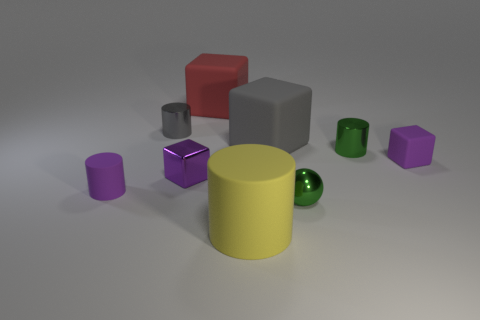Subtract all rubber cubes. How many cubes are left? 1 Subtract all cylinders. How many objects are left? 5 Subtract 1 cylinders. How many cylinders are left? 3 Subtract all red cubes. How many cubes are left? 3 Subtract all gray cylinders. Subtract all gray blocks. How many cylinders are left? 3 Subtract all blue balls. How many gray cylinders are left? 1 Subtract all large yellow matte balls. Subtract all tiny green metal spheres. How many objects are left? 8 Add 3 tiny shiny blocks. How many tiny shiny blocks are left? 4 Add 1 big purple spheres. How many big purple spheres exist? 1 Subtract 0 yellow balls. How many objects are left? 9 